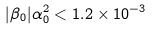Convert formula to latex. <formula><loc_0><loc_0><loc_500><loc_500>| \beta _ { 0 } | \alpha _ { 0 } ^ { 2 } < 1 . 2 \times 1 0 ^ { - 3 }</formula> 